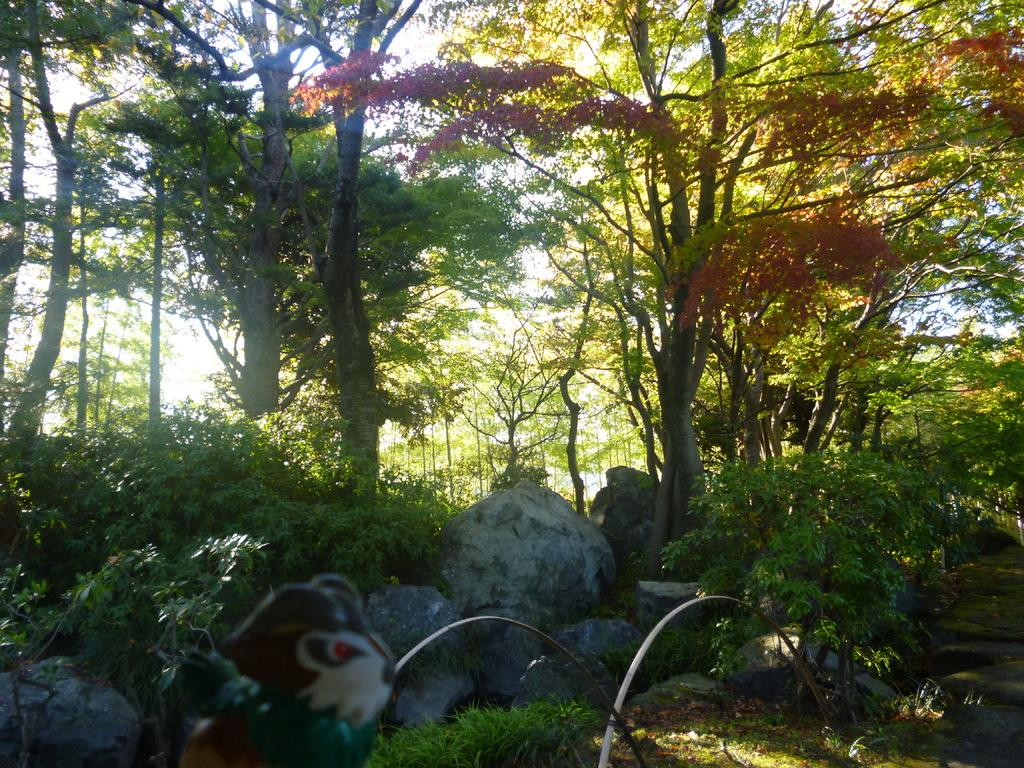What type of natural elements can be seen in the image? There are stones and trees in the image. What colors are present on the trees in the image? The trees have green and brown colors. What is the color of the sky in the image? The sky is white in the image. Can you describe the colorful object in the image? Unfortunately, the facts provided do not give any information about the colorful object, so we cannot describe it. Is the daughter of the person who took the photo visible in the image? There is no information about the person who took the photo or their daughter, so we cannot determine if she is visible in the image. Is there a volcano erupting in the image? There is no mention of a volcano in the provided facts, so we cannot determine if one is present or erupting in the image. 